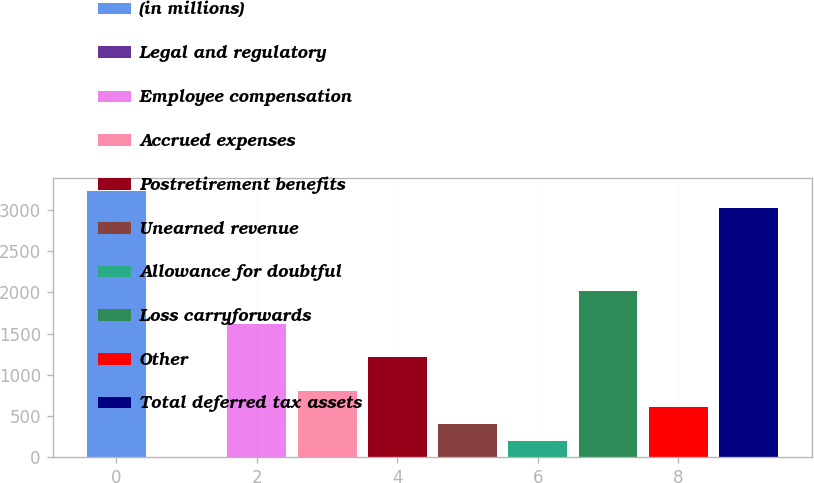Convert chart. <chart><loc_0><loc_0><loc_500><loc_500><bar_chart><fcel>(in millions)<fcel>Legal and regulatory<fcel>Employee compensation<fcel>Accrued expenses<fcel>Postretirement benefits<fcel>Unearned revenue<fcel>Allowance for doubtful<fcel>Loss carryforwards<fcel>Other<fcel>Total deferred tax assets<nl><fcel>3227.6<fcel>2<fcel>1614.8<fcel>808.4<fcel>1211.6<fcel>405.2<fcel>203.6<fcel>2018<fcel>606.8<fcel>3026<nl></chart> 